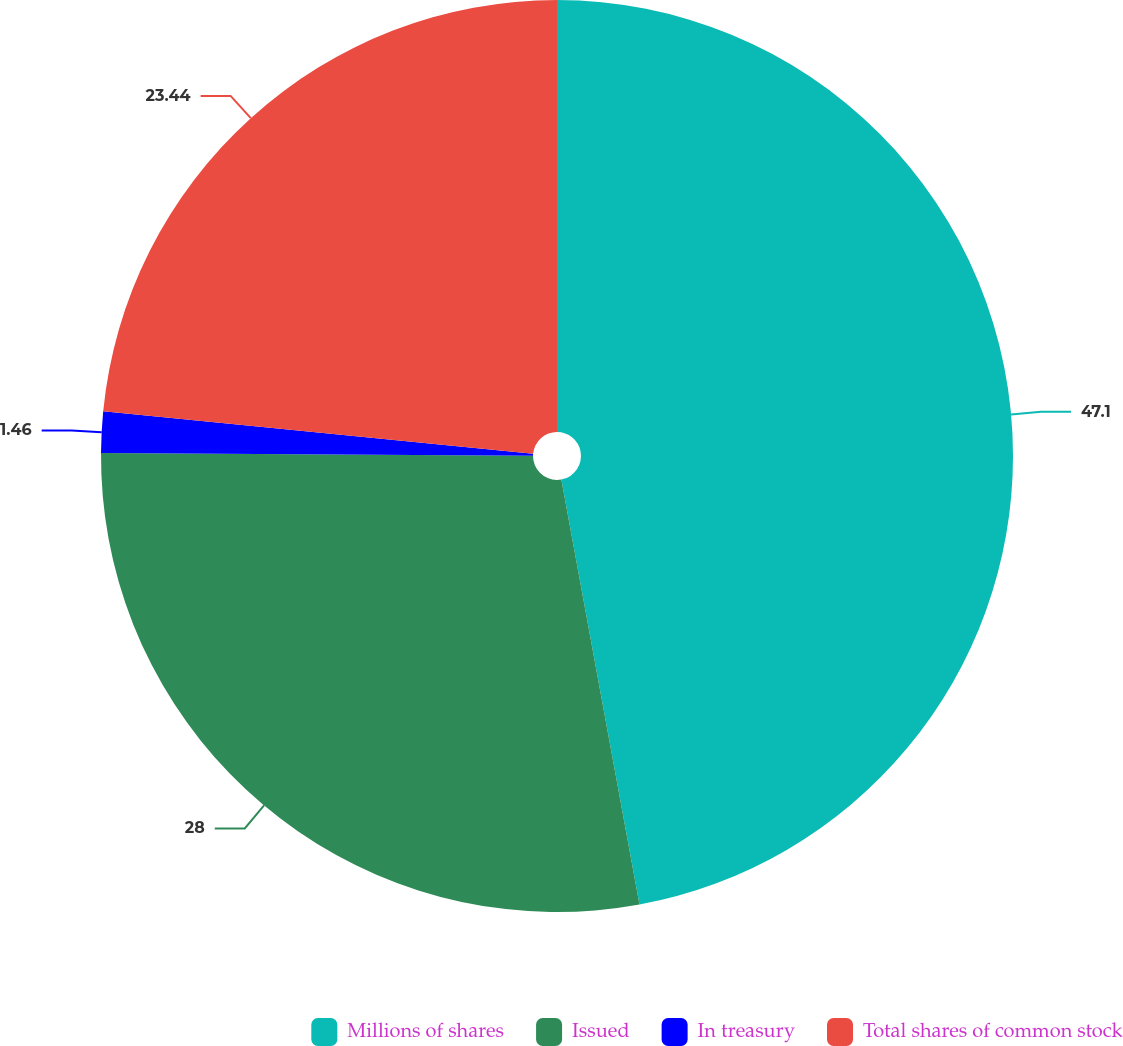Convert chart to OTSL. <chart><loc_0><loc_0><loc_500><loc_500><pie_chart><fcel>Millions of shares<fcel>Issued<fcel>In treasury<fcel>Total shares of common stock<nl><fcel>47.11%<fcel>28.0%<fcel>1.46%<fcel>23.44%<nl></chart> 